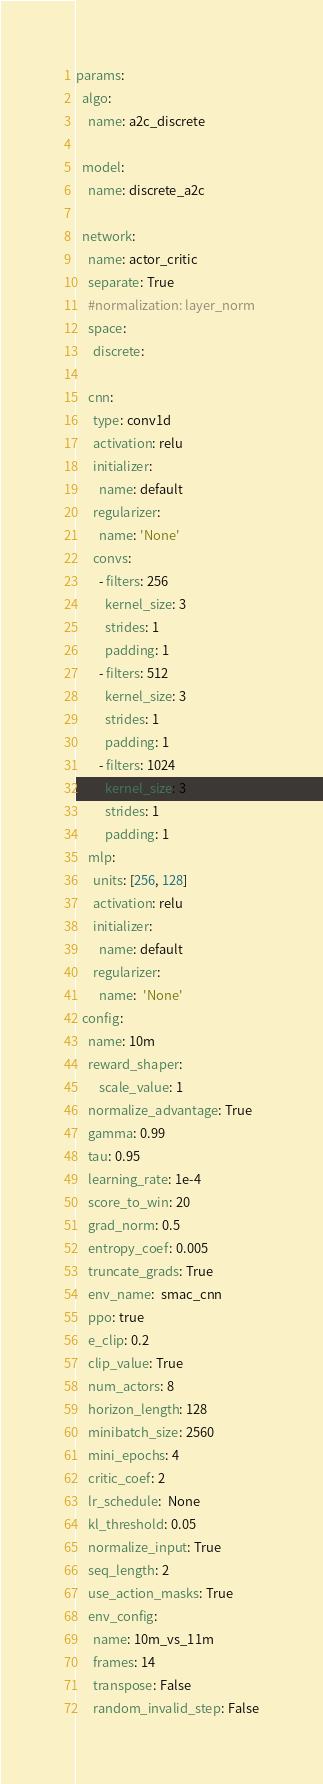<code> <loc_0><loc_0><loc_500><loc_500><_YAML_>params:  
  algo:
    name: a2c_discrete

  model:
    name: discrete_a2c

  network:
    name: actor_critic
    separate: True
    #normalization: layer_norm
    space: 
      discrete:
      
    cnn:
      type: conv1d
      activation: relu
      initializer:
        name: default
      regularizer:
        name: 'None'
      convs:    
        - filters: 256
          kernel_size: 3
          strides: 1
          padding: 1
        - filters: 512
          kernel_size: 3
          strides: 1
          padding: 1
        - filters: 1024
          kernel_size: 3
          strides: 1
          padding: 1
    mlp:
      units: [256, 128]
      activation: relu
      initializer:
        name: default 
      regularizer:
        name:  'None'
  config:
    name: 10m
    reward_shaper:
        scale_value: 1
    normalize_advantage: True
    gamma: 0.99
    tau: 0.95
    learning_rate: 1e-4
    score_to_win: 20
    grad_norm: 0.5
    entropy_coef: 0.005
    truncate_grads: True
    env_name:  smac_cnn
    ppo: true
    e_clip: 0.2
    clip_value: True
    num_actors: 8
    horizon_length: 128
    minibatch_size: 2560
    mini_epochs: 4
    critic_coef: 2
    lr_schedule:  None
    kl_threshold: 0.05
    normalize_input: True
    seq_length: 2
    use_action_masks: True
    env_config:
      name: 10m_vs_11m
      frames: 14
      transpose: False
      random_invalid_step: False</code> 